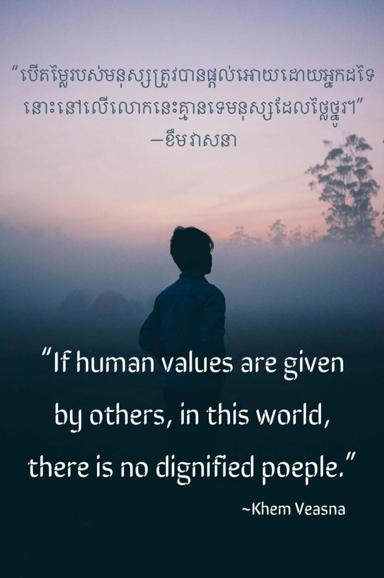How does the setting of the image contribute to the meaning of the quote? The misty and somewhat obscured background in the image symbolizes the unclear and often indistinct nature of externally imposed values. The silhouette of the individual facing away underscores a sense of introspection and self-discovery, emphasizing the journey towards finding one's own values amidst the fog of societal expectations. 